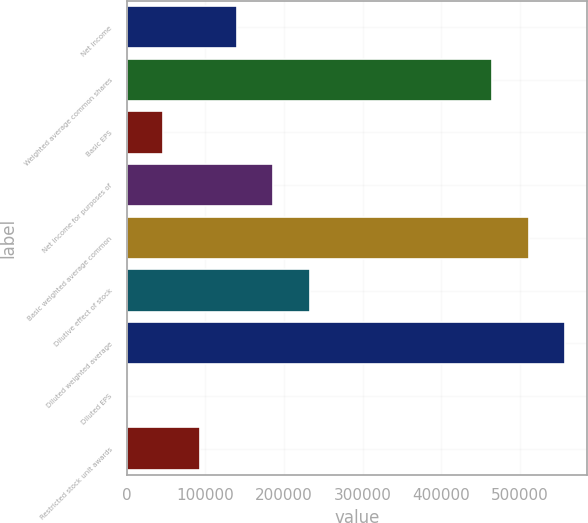<chart> <loc_0><loc_0><loc_500><loc_500><bar_chart><fcel>Net income<fcel>Weighted average common shares<fcel>Basic EPS<fcel>Net income for purposes of<fcel>Basic weighted average common<fcel>Dilutive effect of stock<fcel>Diluted weighted average<fcel>Diluted EPS<fcel>Restricted stock unit awards<nl><fcel>139700<fcel>464236<fcel>46568.7<fcel>186266<fcel>510802<fcel>232832<fcel>557367<fcel>3.03<fcel>93134.4<nl></chart> 